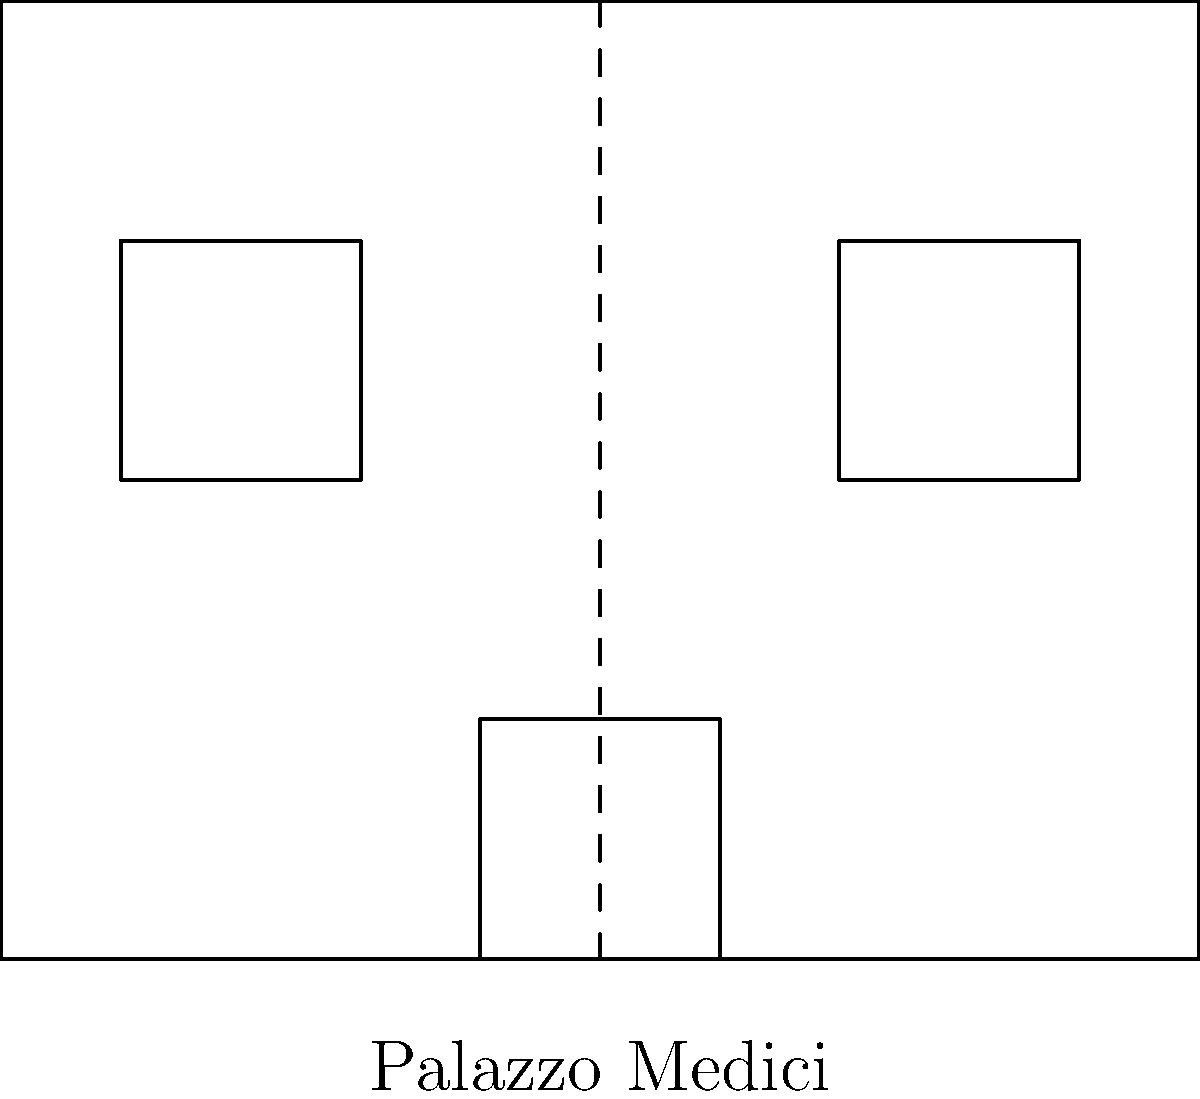The architectural plan shown represents the facade of Palazzo Medici in Florence, closely associated with Catherine de' Medici, a powerful female figure in Renaissance politics. Identify the type of symmetry exhibited in this design and explain its significance in Renaissance architecture. To identify the type of symmetry in the Palazzo Medici facade:

1. Observe the overall structure:
   - The building has a rectangular shape.
   - There's a central entrance.
   - Windows are placed on either side of the entrance.

2. Identify the axis of symmetry:
   - A vertical dashed line runs through the center of the facade.

3. Compare elements on both sides of the axis:
   - The windows on the left and right are identical in size and placement.
   - The overall shape is mirrored on both sides.

4. Conclude the type of symmetry:
   - This is reflectional symmetry (also called mirror symmetry or line symmetry).

5. Significance in Renaissance architecture:
   - Symmetry represented harmony, balance, and perfection.
   - It reflected the Renaissance ideal of rational order.
   - Symmetrical designs were associated with classical Greek and Roman architecture, which Renaissance architects sought to emulate.

6. Relevance to Catherine de' Medici:
   - The use of symmetry in buildings associated with powerful women like Catherine de' Medici demonstrated their adherence to Renaissance ideals.
   - It symbolized their legitimacy and connection to classical traditions of governance.

The reflectional symmetry in this facade exemplifies how Renaissance architecture, even when associated with influential women, adhered to principles of balance and classical inspiration.
Answer: Reflectional symmetry 